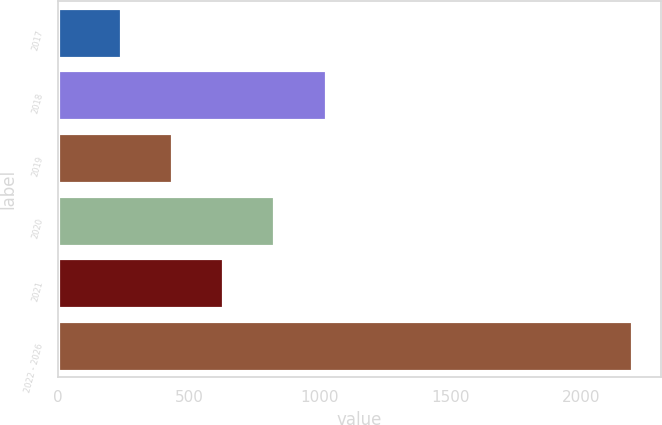Convert chart. <chart><loc_0><loc_0><loc_500><loc_500><bar_chart><fcel>2017<fcel>2018<fcel>2019<fcel>2020<fcel>2021<fcel>2022 - 2026<nl><fcel>242<fcel>1022<fcel>437<fcel>827<fcel>632<fcel>2192<nl></chart> 